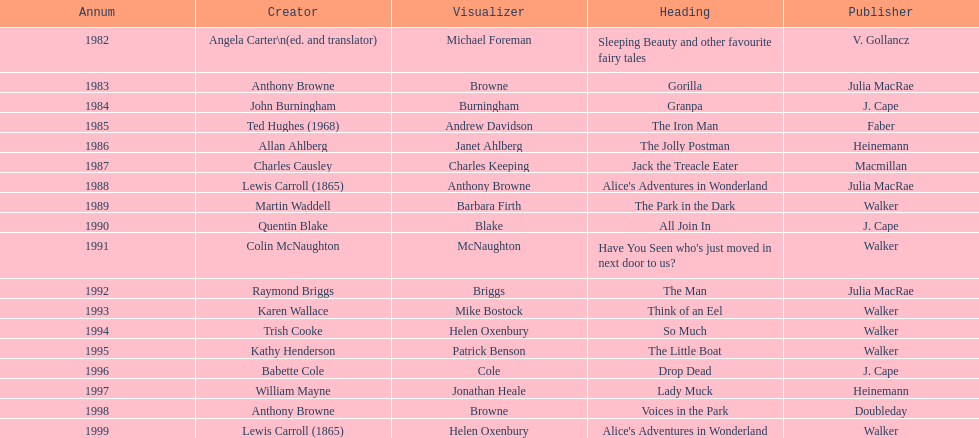Which title was after the year 1991 but before the year 1993? The Man. 